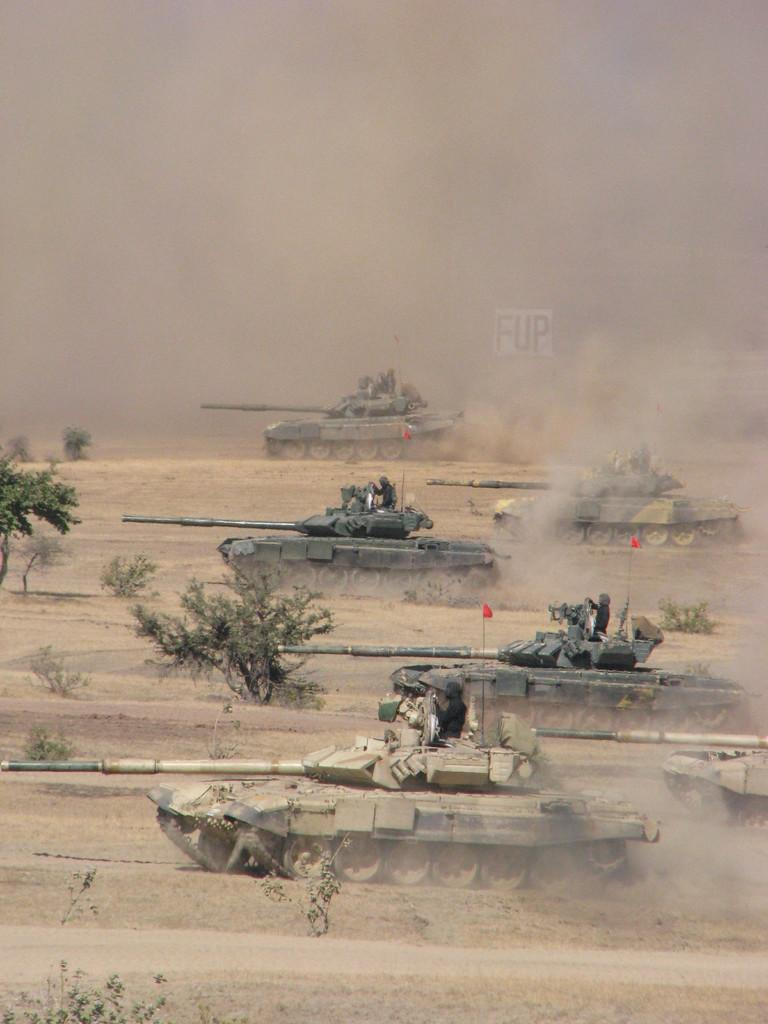What type of vehicles are on the ground in the image? There are battle tanks on the ground in the image. Are there any people associated with the vehicles? Yes, people are present on the tanks. What type of natural elements can be seen in the image? There are trees and plants in the image. Where are all the elements in the image located? The tanks, people, trees, and plants are all situated on the ground. What type of scissors are being used to cut the trees in the image? There are no scissors present in the image, nor are any trees being cut. 